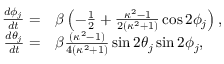Convert formula to latex. <formula><loc_0><loc_0><loc_500><loc_500>\begin{array} { r l } { \frac { d \phi _ { j } } { d t } = } & \beta \left ( - \frac { 1 } { 2 } + \frac { \kappa ^ { 2 } - 1 } { 2 ( \kappa ^ { 2 } + 1 ) } \cos 2 \phi _ { j } \right ) , } \\ { \frac { d \theta _ { j } } { d t } = } & \beta \frac { ( \kappa ^ { 2 } - 1 ) } { 4 ( \kappa ^ { 2 } + 1 ) } \sin 2 \theta _ { j } \sin 2 \phi _ { j } , } \end{array}</formula> 